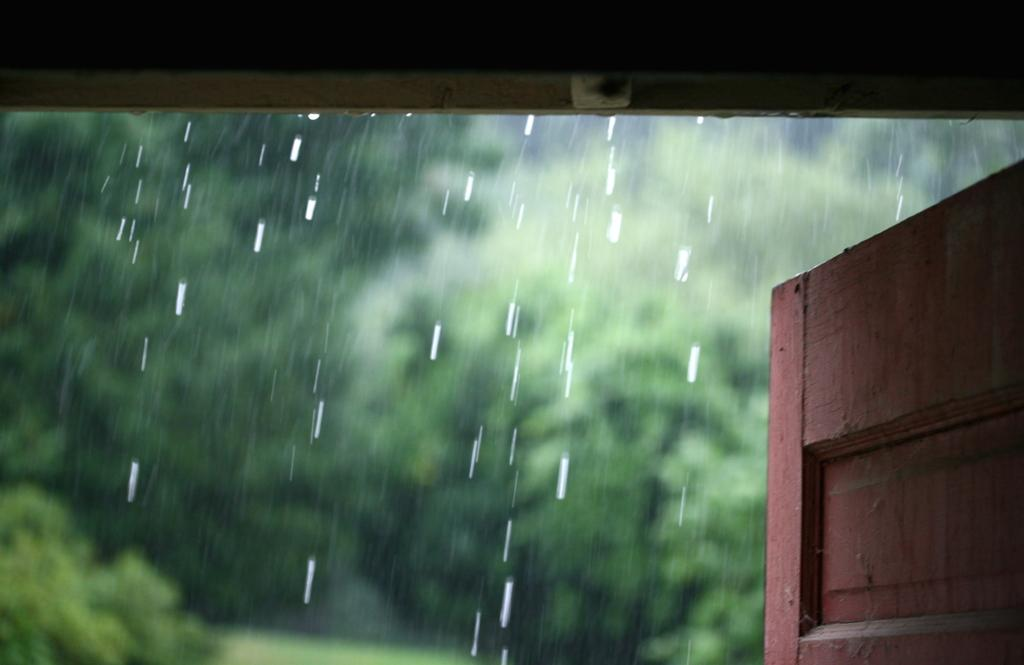What is the main object in the image? There is a door in the image. What can be seen on the door? There are water drops on the door. What type of natural elements are present in the image? There are trees in the image. What is the name of the person who gave birth in the image? There is no mention of a person giving birth in the image. 